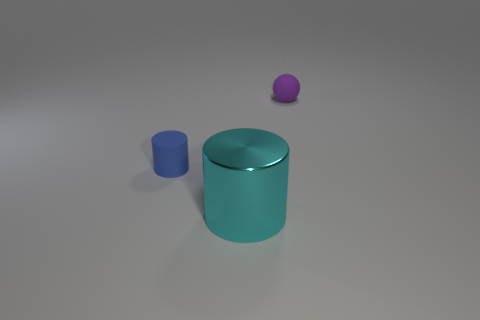How many tiny things are either red metallic spheres or metallic cylinders?
Offer a very short reply. 0. Are there any cyan shiny spheres of the same size as the purple object?
Make the answer very short. No. How many metallic things are either small cyan balls or tiny blue cylinders?
Offer a very short reply. 0. How many large cyan shiny cylinders are there?
Ensure brevity in your answer.  1. Do the object in front of the small matte cylinder and the small object that is behind the blue rubber cylinder have the same material?
Your answer should be compact. No. There is a blue cylinder that is made of the same material as the tiny sphere; what size is it?
Make the answer very short. Small. The large metal object in front of the small blue cylinder has what shape?
Give a very brief answer. Cylinder. There is a cylinder in front of the blue object; is it the same color as the tiny object behind the blue matte thing?
Make the answer very short. No. Are there any big green blocks?
Your response must be concise. No. The tiny object in front of the thing that is behind the small matte thing that is in front of the rubber ball is what shape?
Provide a succinct answer. Cylinder. 